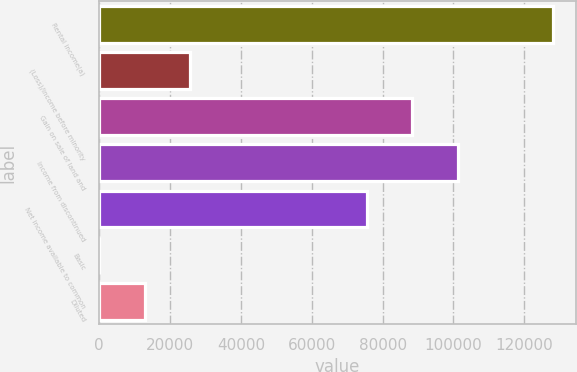Convert chart to OTSL. <chart><loc_0><loc_0><loc_500><loc_500><bar_chart><fcel>Rental income(a)<fcel>(Loss)/income before minority<fcel>Gain on sale of land and<fcel>Income from discontinued<fcel>Net income available to common<fcel>Basic<fcel>Diluted<nl><fcel>128192<fcel>25638.8<fcel>88389.1<fcel>101208<fcel>75570<fcel>0.56<fcel>12819.7<nl></chart> 